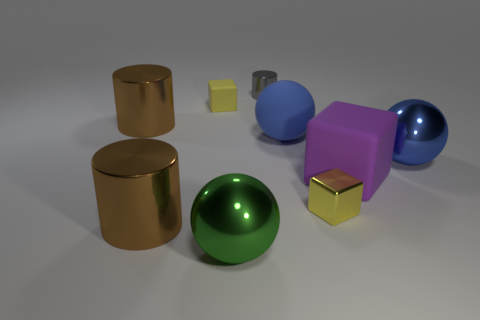Subtract all big purple cubes. How many cubes are left? 2 Subtract all brown cylinders. How many cylinders are left? 1 Subtract all purple cylinders. Subtract all brown spheres. How many cylinders are left? 3 Subtract all purple cubes. How many purple cylinders are left? 0 Subtract all metallic spheres. Subtract all brown cylinders. How many objects are left? 5 Add 7 yellow cubes. How many yellow cubes are left? 9 Add 8 large blue shiny spheres. How many large blue shiny spheres exist? 9 Add 1 metal blocks. How many objects exist? 10 Subtract 0 red balls. How many objects are left? 9 Subtract all balls. How many objects are left? 6 